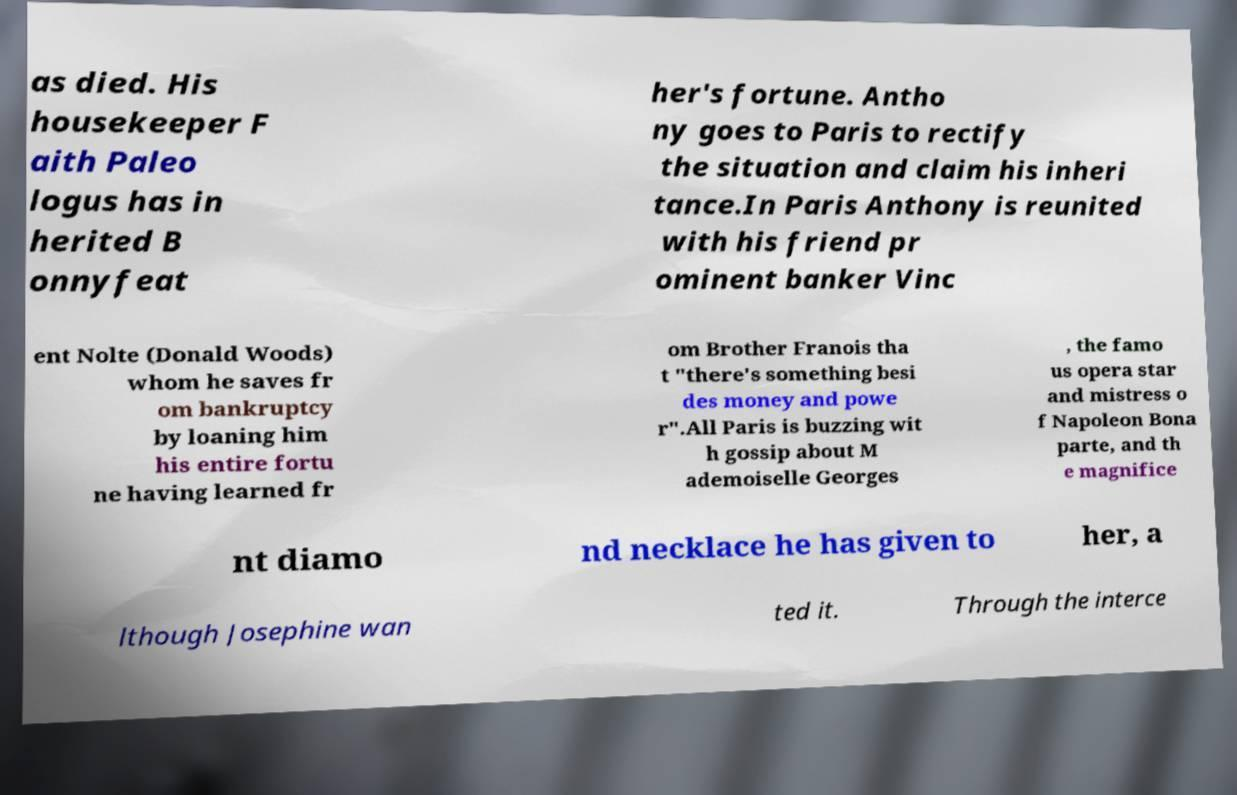Can you read and provide the text displayed in the image?This photo seems to have some interesting text. Can you extract and type it out for me? as died. His housekeeper F aith Paleo logus has in herited B onnyfeat her's fortune. Antho ny goes to Paris to rectify the situation and claim his inheri tance.In Paris Anthony is reunited with his friend pr ominent banker Vinc ent Nolte (Donald Woods) whom he saves fr om bankruptcy by loaning him his entire fortu ne having learned fr om Brother Franois tha t "there's something besi des money and powe r".All Paris is buzzing wit h gossip about M ademoiselle Georges , the famo us opera star and mistress o f Napoleon Bona parte, and th e magnifice nt diamo nd necklace he has given to her, a lthough Josephine wan ted it. Through the interce 